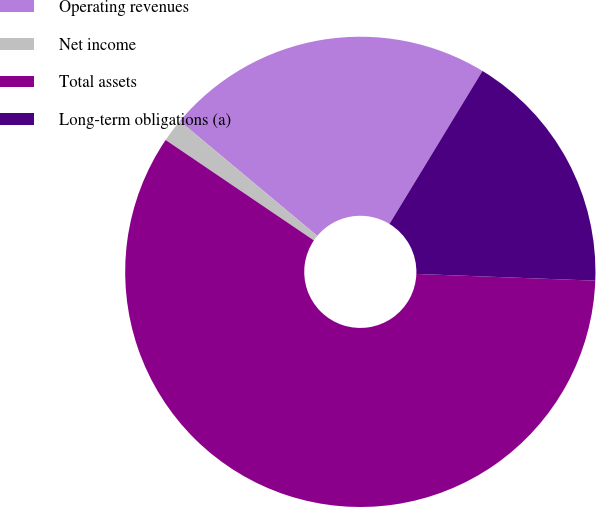<chart> <loc_0><loc_0><loc_500><loc_500><pie_chart><fcel>Operating revenues<fcel>Net income<fcel>Total assets<fcel>Long-term obligations (a)<nl><fcel>22.62%<fcel>1.6%<fcel>58.88%<fcel>16.9%<nl></chart> 